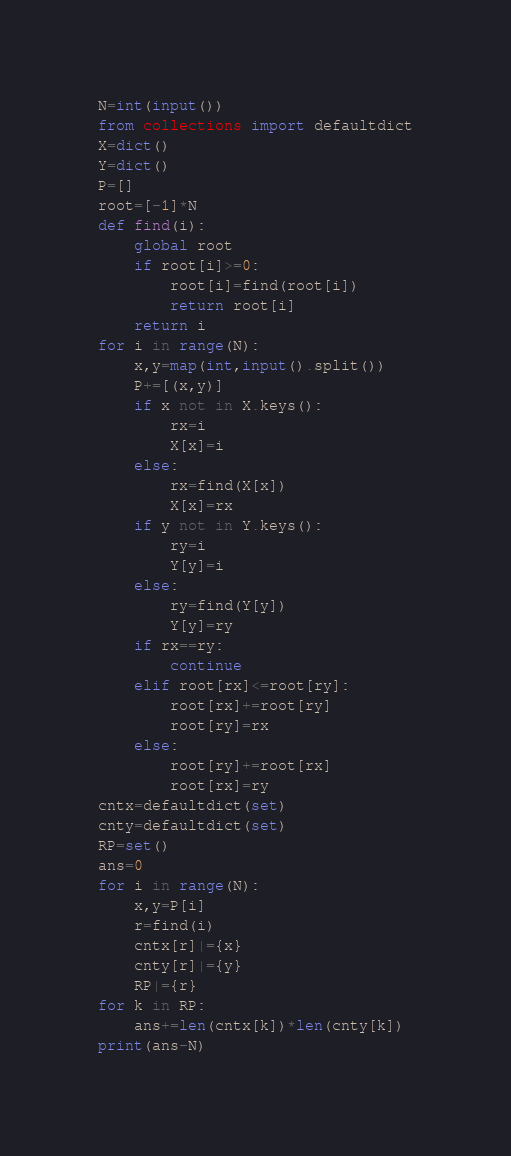Convert code to text. <code><loc_0><loc_0><loc_500><loc_500><_Python_>N=int(input())
from collections import defaultdict
X=dict()
Y=dict()
P=[]
root=[-1]*N
def find(i):
    global root
    if root[i]>=0:
        root[i]=find(root[i])
        return root[i]
    return i
for i in range(N):
    x,y=map(int,input().split())
    P+=[(x,y)]
    if x not in X.keys():
        rx=i
        X[x]=i
    else:
        rx=find(X[x])
        X[x]=rx
    if y not in Y.keys():
        ry=i
        Y[y]=i
    else:
        ry=find(Y[y])
        Y[y]=ry
    if rx==ry:
        continue
    elif root[rx]<=root[ry]:
        root[rx]+=root[ry]
        root[ry]=rx
    else:
        root[ry]+=root[rx]
        root[rx]=ry
cntx=defaultdict(set)
cnty=defaultdict(set)
RP=set()
ans=0
for i in range(N):
    x,y=P[i]
    r=find(i)
    cntx[r]|={x}
    cnty[r]|={y}
    RP|={r}
for k in RP:
    ans+=len(cntx[k])*len(cnty[k])
print(ans-N)
</code> 